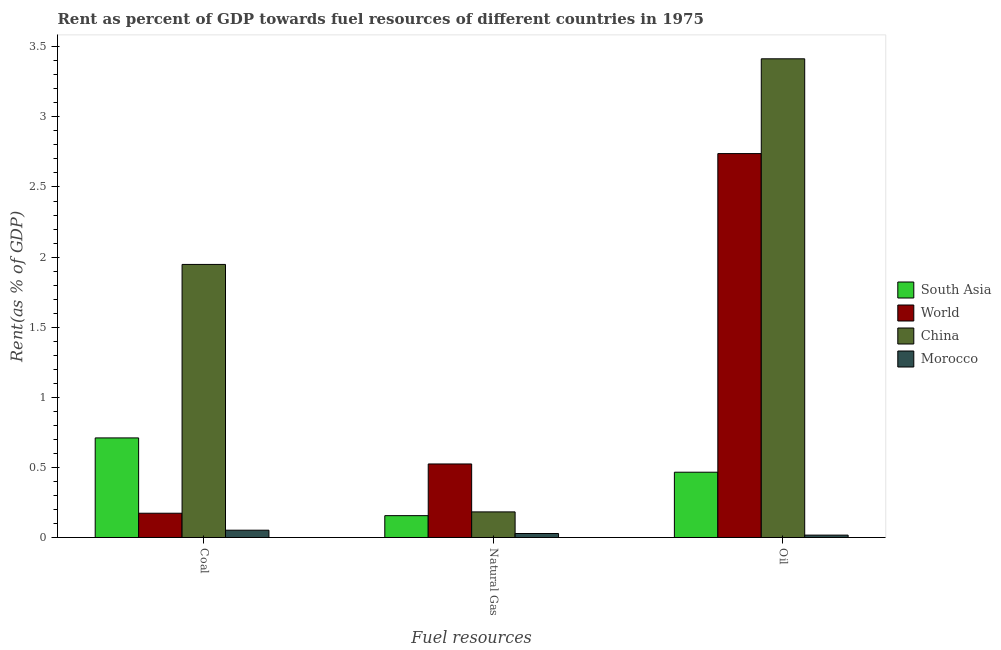How many different coloured bars are there?
Ensure brevity in your answer.  4. Are the number of bars on each tick of the X-axis equal?
Make the answer very short. Yes. What is the label of the 3rd group of bars from the left?
Provide a succinct answer. Oil. What is the rent towards oil in Morocco?
Your answer should be very brief. 0.02. Across all countries, what is the maximum rent towards coal?
Your answer should be compact. 1.95. Across all countries, what is the minimum rent towards coal?
Ensure brevity in your answer.  0.05. In which country was the rent towards coal minimum?
Provide a short and direct response. Morocco. What is the total rent towards natural gas in the graph?
Your answer should be very brief. 0.89. What is the difference between the rent towards coal in South Asia and that in Morocco?
Provide a succinct answer. 0.66. What is the difference between the rent towards oil in Morocco and the rent towards natural gas in World?
Your response must be concise. -0.51. What is the average rent towards oil per country?
Provide a succinct answer. 1.66. What is the difference between the rent towards coal and rent towards natural gas in South Asia?
Keep it short and to the point. 0.55. In how many countries, is the rent towards natural gas greater than 1.5 %?
Your answer should be compact. 0. What is the ratio of the rent towards coal in South Asia to that in Morocco?
Your answer should be very brief. 13.64. Is the difference between the rent towards coal in Morocco and China greater than the difference between the rent towards natural gas in Morocco and China?
Provide a succinct answer. No. What is the difference between the highest and the second highest rent towards oil?
Ensure brevity in your answer.  0.68. What is the difference between the highest and the lowest rent towards oil?
Offer a very short reply. 3.4. What does the 1st bar from the right in Oil represents?
Your response must be concise. Morocco. Is it the case that in every country, the sum of the rent towards coal and rent towards natural gas is greater than the rent towards oil?
Keep it short and to the point. No. How many bars are there?
Ensure brevity in your answer.  12. Are all the bars in the graph horizontal?
Provide a short and direct response. No. How are the legend labels stacked?
Make the answer very short. Vertical. What is the title of the graph?
Ensure brevity in your answer.  Rent as percent of GDP towards fuel resources of different countries in 1975. What is the label or title of the X-axis?
Offer a very short reply. Fuel resources. What is the label or title of the Y-axis?
Keep it short and to the point. Rent(as % of GDP). What is the Rent(as % of GDP) of South Asia in Coal?
Offer a very short reply. 0.71. What is the Rent(as % of GDP) in World in Coal?
Offer a terse response. 0.17. What is the Rent(as % of GDP) in China in Coal?
Offer a very short reply. 1.95. What is the Rent(as % of GDP) of Morocco in Coal?
Give a very brief answer. 0.05. What is the Rent(as % of GDP) in South Asia in Natural Gas?
Make the answer very short. 0.16. What is the Rent(as % of GDP) of World in Natural Gas?
Offer a terse response. 0.52. What is the Rent(as % of GDP) of China in Natural Gas?
Provide a succinct answer. 0.18. What is the Rent(as % of GDP) in Morocco in Natural Gas?
Give a very brief answer. 0.03. What is the Rent(as % of GDP) in South Asia in Oil?
Your answer should be compact. 0.47. What is the Rent(as % of GDP) of World in Oil?
Give a very brief answer. 2.74. What is the Rent(as % of GDP) in China in Oil?
Provide a short and direct response. 3.41. What is the Rent(as % of GDP) in Morocco in Oil?
Make the answer very short. 0.02. Across all Fuel resources, what is the maximum Rent(as % of GDP) of South Asia?
Your response must be concise. 0.71. Across all Fuel resources, what is the maximum Rent(as % of GDP) in World?
Make the answer very short. 2.74. Across all Fuel resources, what is the maximum Rent(as % of GDP) of China?
Your answer should be compact. 3.41. Across all Fuel resources, what is the maximum Rent(as % of GDP) of Morocco?
Offer a terse response. 0.05. Across all Fuel resources, what is the minimum Rent(as % of GDP) of South Asia?
Your answer should be very brief. 0.16. Across all Fuel resources, what is the minimum Rent(as % of GDP) in World?
Make the answer very short. 0.17. Across all Fuel resources, what is the minimum Rent(as % of GDP) of China?
Your answer should be very brief. 0.18. Across all Fuel resources, what is the minimum Rent(as % of GDP) in Morocco?
Make the answer very short. 0.02. What is the total Rent(as % of GDP) of South Asia in the graph?
Your answer should be very brief. 1.33. What is the total Rent(as % of GDP) in World in the graph?
Offer a very short reply. 3.44. What is the total Rent(as % of GDP) of China in the graph?
Your answer should be very brief. 5.54. What is the total Rent(as % of GDP) in Morocco in the graph?
Your answer should be very brief. 0.1. What is the difference between the Rent(as % of GDP) in South Asia in Coal and that in Natural Gas?
Your answer should be compact. 0.55. What is the difference between the Rent(as % of GDP) in World in Coal and that in Natural Gas?
Provide a succinct answer. -0.35. What is the difference between the Rent(as % of GDP) in China in Coal and that in Natural Gas?
Keep it short and to the point. 1.76. What is the difference between the Rent(as % of GDP) of Morocco in Coal and that in Natural Gas?
Offer a terse response. 0.02. What is the difference between the Rent(as % of GDP) in South Asia in Coal and that in Oil?
Your answer should be very brief. 0.24. What is the difference between the Rent(as % of GDP) in World in Coal and that in Oil?
Offer a terse response. -2.57. What is the difference between the Rent(as % of GDP) in China in Coal and that in Oil?
Provide a short and direct response. -1.47. What is the difference between the Rent(as % of GDP) in Morocco in Coal and that in Oil?
Offer a terse response. 0.04. What is the difference between the Rent(as % of GDP) of South Asia in Natural Gas and that in Oil?
Give a very brief answer. -0.31. What is the difference between the Rent(as % of GDP) in World in Natural Gas and that in Oil?
Offer a terse response. -2.21. What is the difference between the Rent(as % of GDP) of China in Natural Gas and that in Oil?
Offer a terse response. -3.23. What is the difference between the Rent(as % of GDP) of Morocco in Natural Gas and that in Oil?
Keep it short and to the point. 0.01. What is the difference between the Rent(as % of GDP) in South Asia in Coal and the Rent(as % of GDP) in World in Natural Gas?
Your answer should be very brief. 0.19. What is the difference between the Rent(as % of GDP) in South Asia in Coal and the Rent(as % of GDP) in China in Natural Gas?
Make the answer very short. 0.53. What is the difference between the Rent(as % of GDP) in South Asia in Coal and the Rent(as % of GDP) in Morocco in Natural Gas?
Your response must be concise. 0.68. What is the difference between the Rent(as % of GDP) in World in Coal and the Rent(as % of GDP) in China in Natural Gas?
Offer a very short reply. -0.01. What is the difference between the Rent(as % of GDP) in World in Coal and the Rent(as % of GDP) in Morocco in Natural Gas?
Give a very brief answer. 0.14. What is the difference between the Rent(as % of GDP) of China in Coal and the Rent(as % of GDP) of Morocco in Natural Gas?
Your answer should be compact. 1.92. What is the difference between the Rent(as % of GDP) of South Asia in Coal and the Rent(as % of GDP) of World in Oil?
Make the answer very short. -2.03. What is the difference between the Rent(as % of GDP) in South Asia in Coal and the Rent(as % of GDP) in China in Oil?
Offer a terse response. -2.7. What is the difference between the Rent(as % of GDP) of South Asia in Coal and the Rent(as % of GDP) of Morocco in Oil?
Your answer should be compact. 0.69. What is the difference between the Rent(as % of GDP) of World in Coal and the Rent(as % of GDP) of China in Oil?
Offer a terse response. -3.24. What is the difference between the Rent(as % of GDP) in World in Coal and the Rent(as % of GDP) in Morocco in Oil?
Your response must be concise. 0.16. What is the difference between the Rent(as % of GDP) of China in Coal and the Rent(as % of GDP) of Morocco in Oil?
Make the answer very short. 1.93. What is the difference between the Rent(as % of GDP) in South Asia in Natural Gas and the Rent(as % of GDP) in World in Oil?
Provide a short and direct response. -2.58. What is the difference between the Rent(as % of GDP) of South Asia in Natural Gas and the Rent(as % of GDP) of China in Oil?
Your answer should be compact. -3.26. What is the difference between the Rent(as % of GDP) in South Asia in Natural Gas and the Rent(as % of GDP) in Morocco in Oil?
Make the answer very short. 0.14. What is the difference between the Rent(as % of GDP) in World in Natural Gas and the Rent(as % of GDP) in China in Oil?
Offer a very short reply. -2.89. What is the difference between the Rent(as % of GDP) of World in Natural Gas and the Rent(as % of GDP) of Morocco in Oil?
Provide a succinct answer. 0.51. What is the difference between the Rent(as % of GDP) of China in Natural Gas and the Rent(as % of GDP) of Morocco in Oil?
Your response must be concise. 0.17. What is the average Rent(as % of GDP) in South Asia per Fuel resources?
Give a very brief answer. 0.44. What is the average Rent(as % of GDP) in World per Fuel resources?
Give a very brief answer. 1.15. What is the average Rent(as % of GDP) in China per Fuel resources?
Ensure brevity in your answer.  1.85. What is the average Rent(as % of GDP) in Morocco per Fuel resources?
Give a very brief answer. 0.03. What is the difference between the Rent(as % of GDP) of South Asia and Rent(as % of GDP) of World in Coal?
Offer a very short reply. 0.54. What is the difference between the Rent(as % of GDP) of South Asia and Rent(as % of GDP) of China in Coal?
Provide a succinct answer. -1.24. What is the difference between the Rent(as % of GDP) of South Asia and Rent(as % of GDP) of Morocco in Coal?
Make the answer very short. 0.66. What is the difference between the Rent(as % of GDP) of World and Rent(as % of GDP) of China in Coal?
Your response must be concise. -1.77. What is the difference between the Rent(as % of GDP) in World and Rent(as % of GDP) in Morocco in Coal?
Ensure brevity in your answer.  0.12. What is the difference between the Rent(as % of GDP) of China and Rent(as % of GDP) of Morocco in Coal?
Keep it short and to the point. 1.9. What is the difference between the Rent(as % of GDP) in South Asia and Rent(as % of GDP) in World in Natural Gas?
Make the answer very short. -0.37. What is the difference between the Rent(as % of GDP) of South Asia and Rent(as % of GDP) of China in Natural Gas?
Your response must be concise. -0.03. What is the difference between the Rent(as % of GDP) in South Asia and Rent(as % of GDP) in Morocco in Natural Gas?
Ensure brevity in your answer.  0.13. What is the difference between the Rent(as % of GDP) in World and Rent(as % of GDP) in China in Natural Gas?
Provide a short and direct response. 0.34. What is the difference between the Rent(as % of GDP) in World and Rent(as % of GDP) in Morocco in Natural Gas?
Provide a short and direct response. 0.5. What is the difference between the Rent(as % of GDP) of China and Rent(as % of GDP) of Morocco in Natural Gas?
Keep it short and to the point. 0.15. What is the difference between the Rent(as % of GDP) in South Asia and Rent(as % of GDP) in World in Oil?
Offer a very short reply. -2.27. What is the difference between the Rent(as % of GDP) of South Asia and Rent(as % of GDP) of China in Oil?
Your response must be concise. -2.95. What is the difference between the Rent(as % of GDP) of South Asia and Rent(as % of GDP) of Morocco in Oil?
Ensure brevity in your answer.  0.45. What is the difference between the Rent(as % of GDP) of World and Rent(as % of GDP) of China in Oil?
Offer a terse response. -0.68. What is the difference between the Rent(as % of GDP) of World and Rent(as % of GDP) of Morocco in Oil?
Keep it short and to the point. 2.72. What is the difference between the Rent(as % of GDP) in China and Rent(as % of GDP) in Morocco in Oil?
Make the answer very short. 3.4. What is the ratio of the Rent(as % of GDP) in South Asia in Coal to that in Natural Gas?
Give a very brief answer. 4.56. What is the ratio of the Rent(as % of GDP) of World in Coal to that in Natural Gas?
Your response must be concise. 0.33. What is the ratio of the Rent(as % of GDP) in China in Coal to that in Natural Gas?
Your answer should be compact. 10.67. What is the ratio of the Rent(as % of GDP) of Morocco in Coal to that in Natural Gas?
Give a very brief answer. 1.83. What is the ratio of the Rent(as % of GDP) of South Asia in Coal to that in Oil?
Offer a very short reply. 1.53. What is the ratio of the Rent(as % of GDP) in World in Coal to that in Oil?
Give a very brief answer. 0.06. What is the ratio of the Rent(as % of GDP) in China in Coal to that in Oil?
Your answer should be compact. 0.57. What is the ratio of the Rent(as % of GDP) of Morocco in Coal to that in Oil?
Ensure brevity in your answer.  3.08. What is the ratio of the Rent(as % of GDP) of South Asia in Natural Gas to that in Oil?
Give a very brief answer. 0.33. What is the ratio of the Rent(as % of GDP) in World in Natural Gas to that in Oil?
Ensure brevity in your answer.  0.19. What is the ratio of the Rent(as % of GDP) in China in Natural Gas to that in Oil?
Give a very brief answer. 0.05. What is the ratio of the Rent(as % of GDP) of Morocco in Natural Gas to that in Oil?
Your response must be concise. 1.68. What is the difference between the highest and the second highest Rent(as % of GDP) of South Asia?
Your answer should be very brief. 0.24. What is the difference between the highest and the second highest Rent(as % of GDP) of World?
Ensure brevity in your answer.  2.21. What is the difference between the highest and the second highest Rent(as % of GDP) in China?
Provide a succinct answer. 1.47. What is the difference between the highest and the second highest Rent(as % of GDP) of Morocco?
Your response must be concise. 0.02. What is the difference between the highest and the lowest Rent(as % of GDP) of South Asia?
Provide a short and direct response. 0.55. What is the difference between the highest and the lowest Rent(as % of GDP) of World?
Ensure brevity in your answer.  2.57. What is the difference between the highest and the lowest Rent(as % of GDP) in China?
Keep it short and to the point. 3.23. What is the difference between the highest and the lowest Rent(as % of GDP) of Morocco?
Provide a short and direct response. 0.04. 